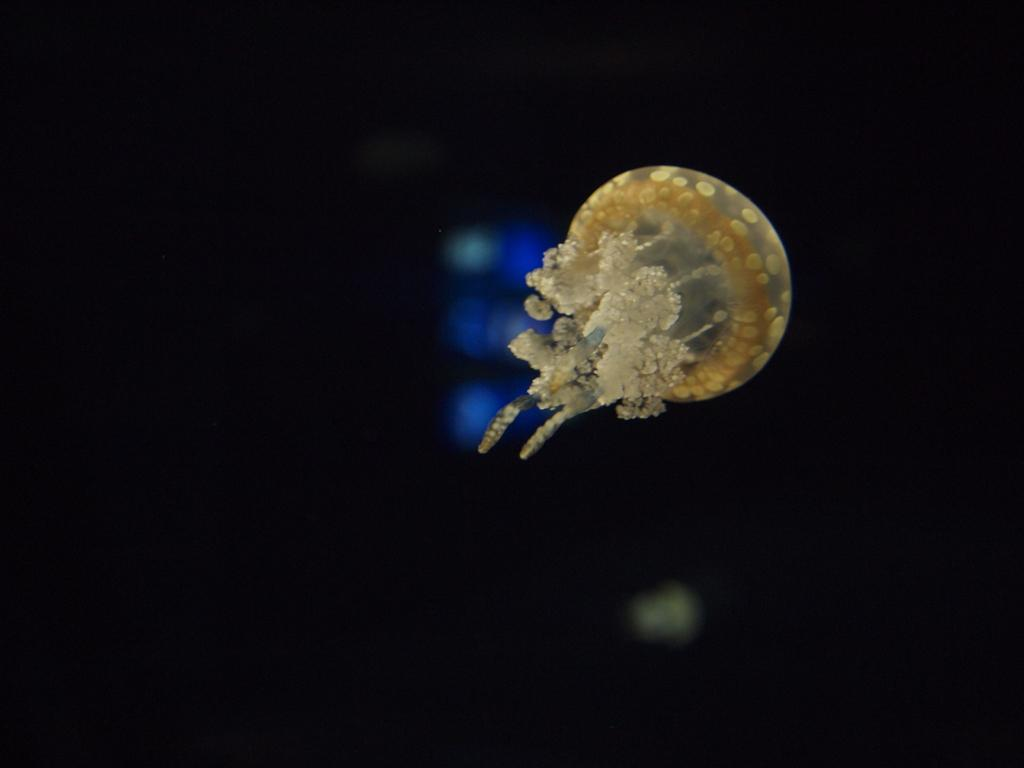What is the main subject in the image? There is a jellyfish in the middle of the image. Can you describe the jellyfish in the image? The jellyfish appears to be floating in the water. What is the surrounding environment of the jellyfish in the image? The jellyfish is in a watery environment, but specific details about the surroundings are not provided. What type of lunch is being served in the image? There is no lunch or any food items present in the image; it features a jellyfish in a watery environment. What color is the polish used on the jellyfish in the image? There is no mention of polish or any human intervention on the jellyfish in the image; it is a natural organism in its environment. 